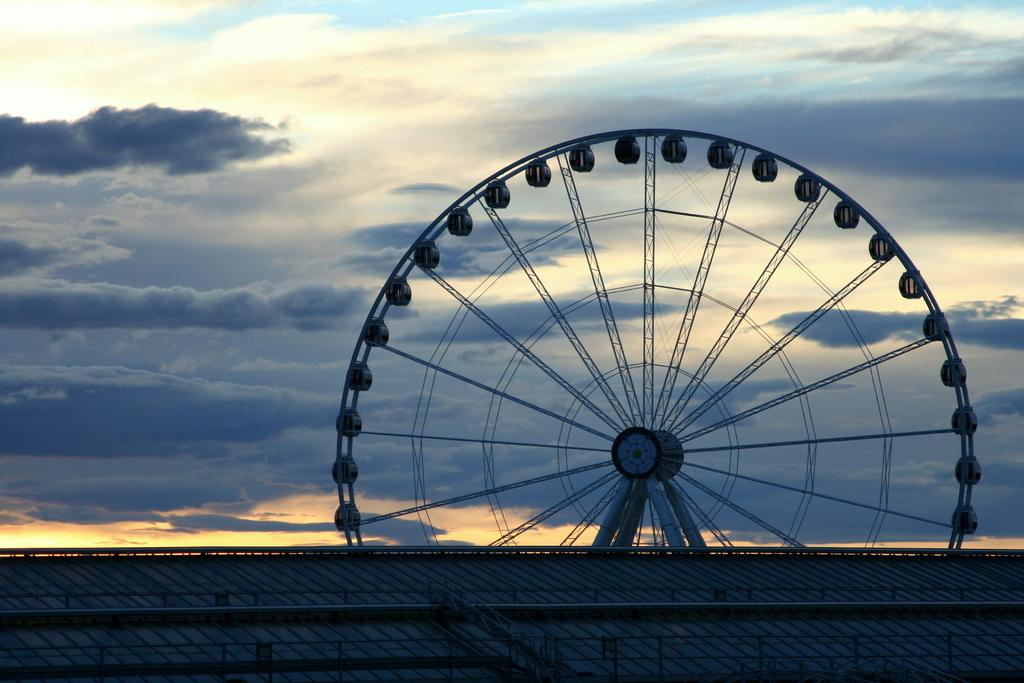What is the main subject in the center of the image? There is a giant wheel in the center of the image. What is located at the bottom of the image? There is a fence at the bottom of the image. What can be seen in the background of the image? The sky is visible in the background of the image. What type of oil is being used to lubricate the giant wheel in the image? There is no mention of oil or any lubrication in the image; the giant wheel appears to be stationary. 